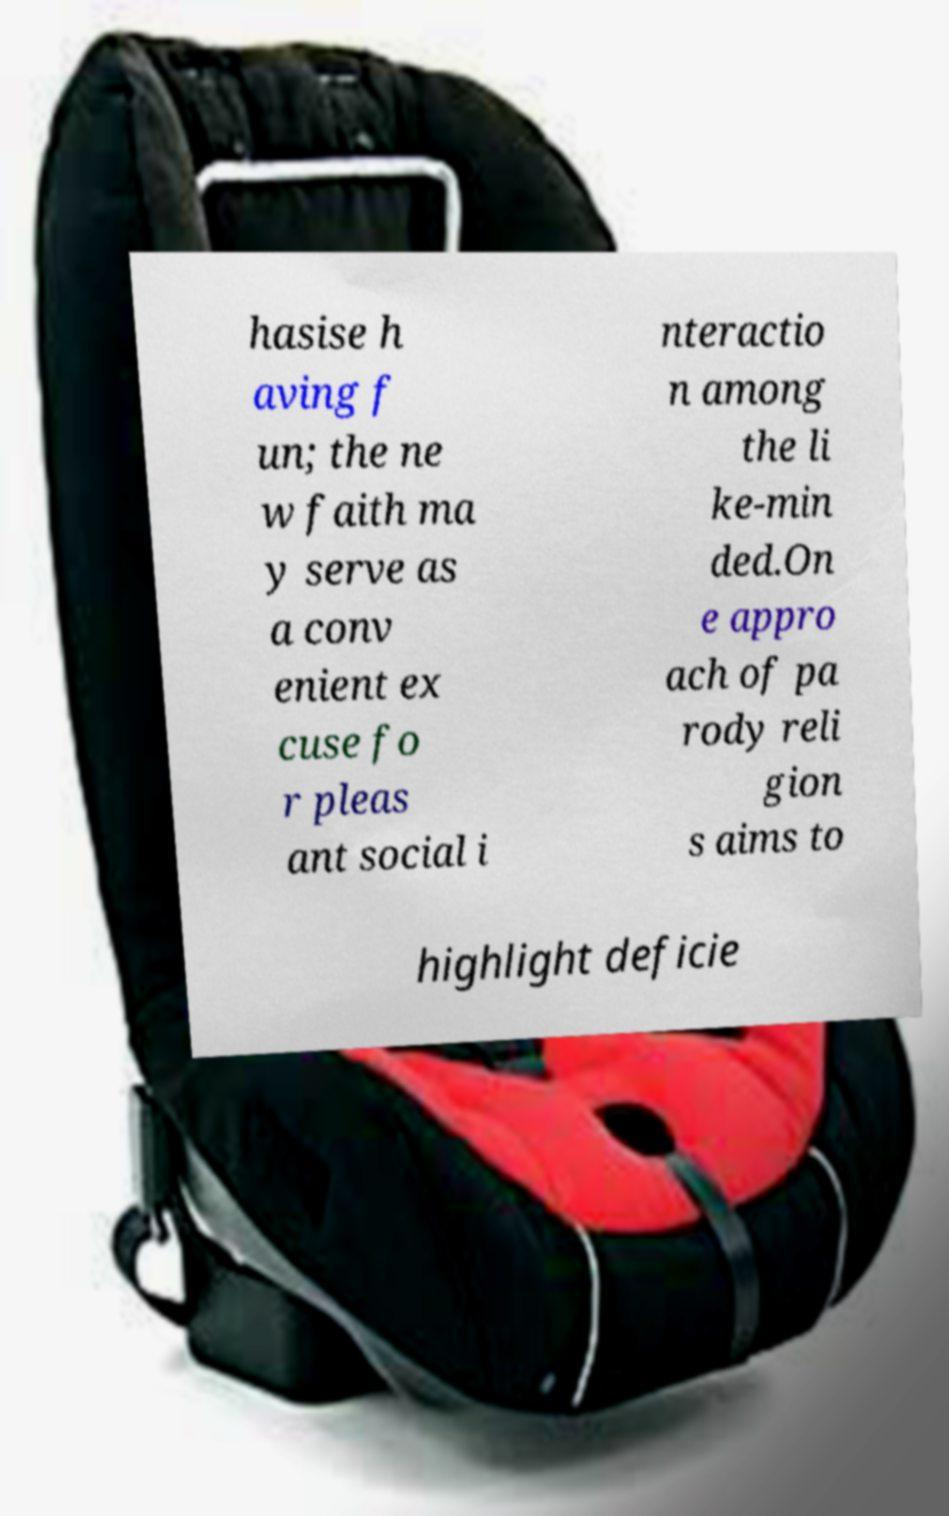What messages or text are displayed in this image? I need them in a readable, typed format. hasise h aving f un; the ne w faith ma y serve as a conv enient ex cuse fo r pleas ant social i nteractio n among the li ke-min ded.On e appro ach of pa rody reli gion s aims to highlight deficie 